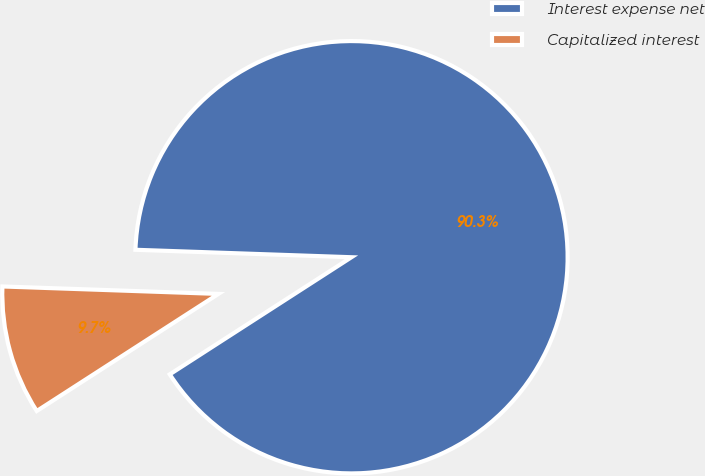Convert chart. <chart><loc_0><loc_0><loc_500><loc_500><pie_chart><fcel>Interest expense net<fcel>Capitalized interest<nl><fcel>90.34%<fcel>9.66%<nl></chart> 